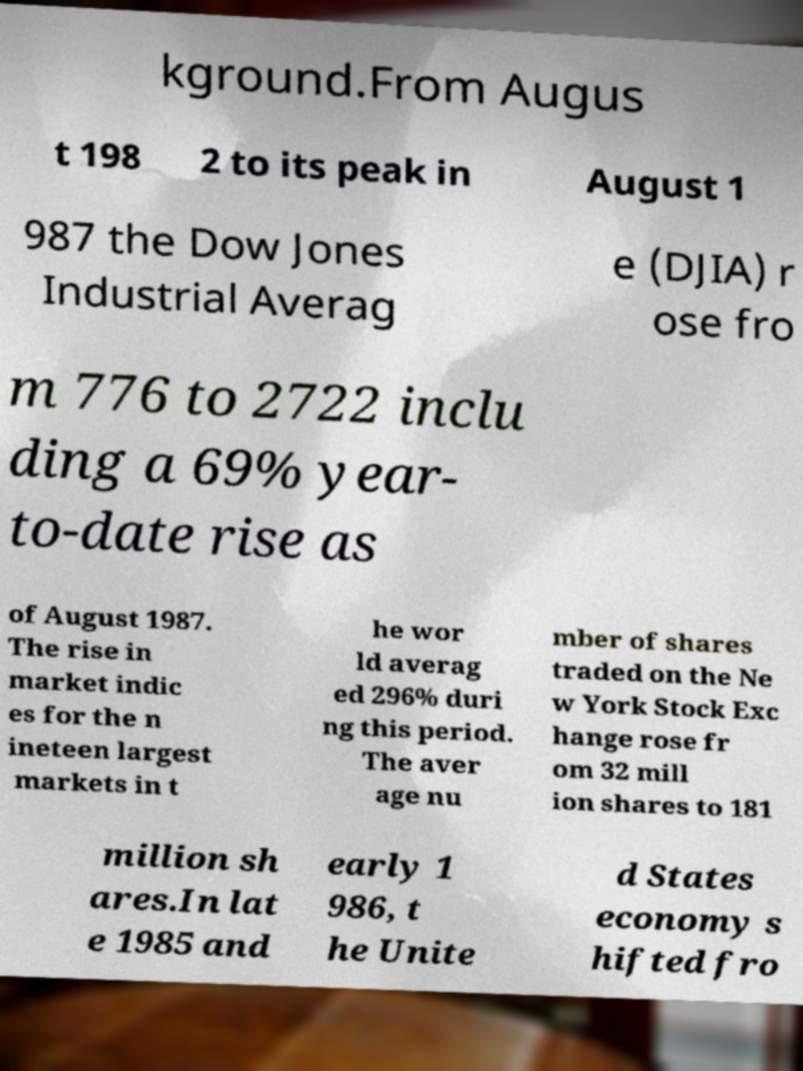Could you extract and type out the text from this image? kground.From Augus t 198 2 to its peak in August 1 987 the Dow Jones Industrial Averag e (DJIA) r ose fro m 776 to 2722 inclu ding a 69% year- to-date rise as of August 1987. The rise in market indic es for the n ineteen largest markets in t he wor ld averag ed 296% duri ng this period. The aver age nu mber of shares traded on the Ne w York Stock Exc hange rose fr om 32 mill ion shares to 181 million sh ares.In lat e 1985 and early 1 986, t he Unite d States economy s hifted fro 